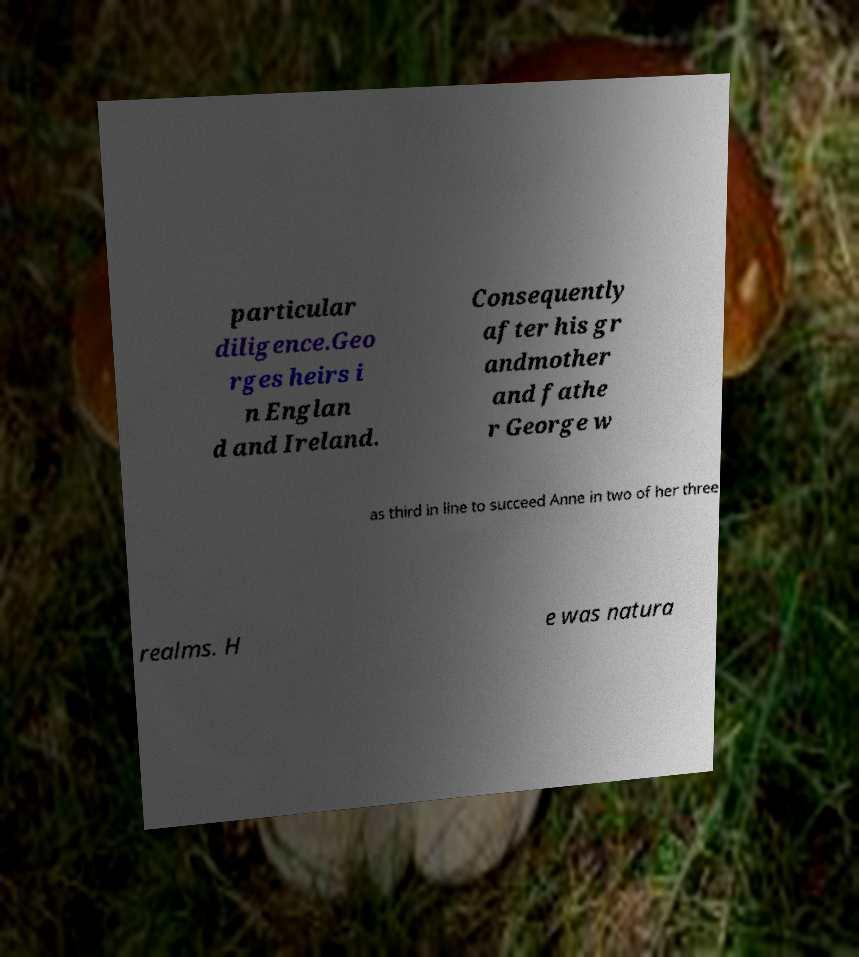Can you accurately transcribe the text from the provided image for me? particular diligence.Geo rges heirs i n Englan d and Ireland. Consequently after his gr andmother and fathe r George w as third in line to succeed Anne in two of her three realms. H e was natura 